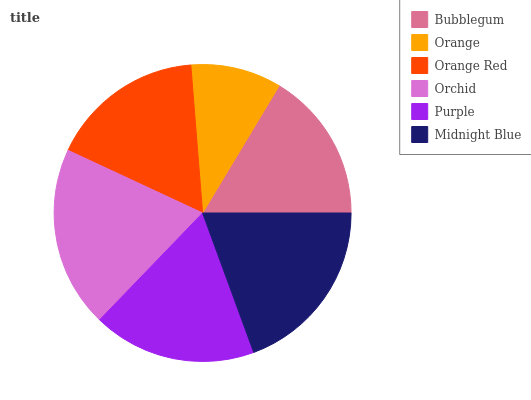Is Orange the minimum?
Answer yes or no. Yes. Is Orchid the maximum?
Answer yes or no. Yes. Is Orange Red the minimum?
Answer yes or no. No. Is Orange Red the maximum?
Answer yes or no. No. Is Orange Red greater than Orange?
Answer yes or no. Yes. Is Orange less than Orange Red?
Answer yes or no. Yes. Is Orange greater than Orange Red?
Answer yes or no. No. Is Orange Red less than Orange?
Answer yes or no. No. Is Purple the high median?
Answer yes or no. Yes. Is Orange Red the low median?
Answer yes or no. Yes. Is Orchid the high median?
Answer yes or no. No. Is Orange the low median?
Answer yes or no. No. 